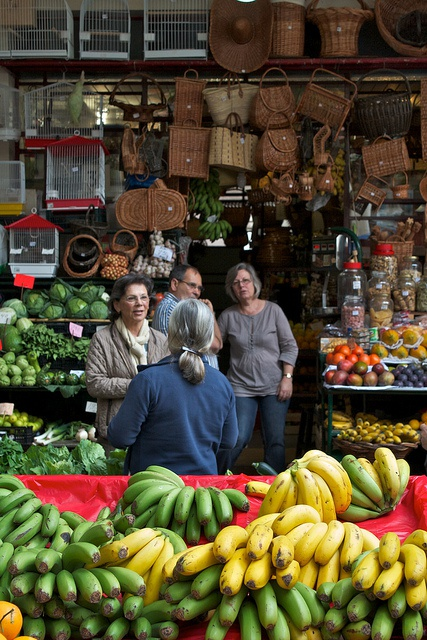Describe the objects in this image and their specific colors. I can see banana in gray, black, darkgreen, and green tones, people in gray, black, navy, darkblue, and blue tones, people in gray and black tones, people in gray, black, darkgray, and maroon tones, and banana in gray, khaki, gold, and olive tones in this image. 